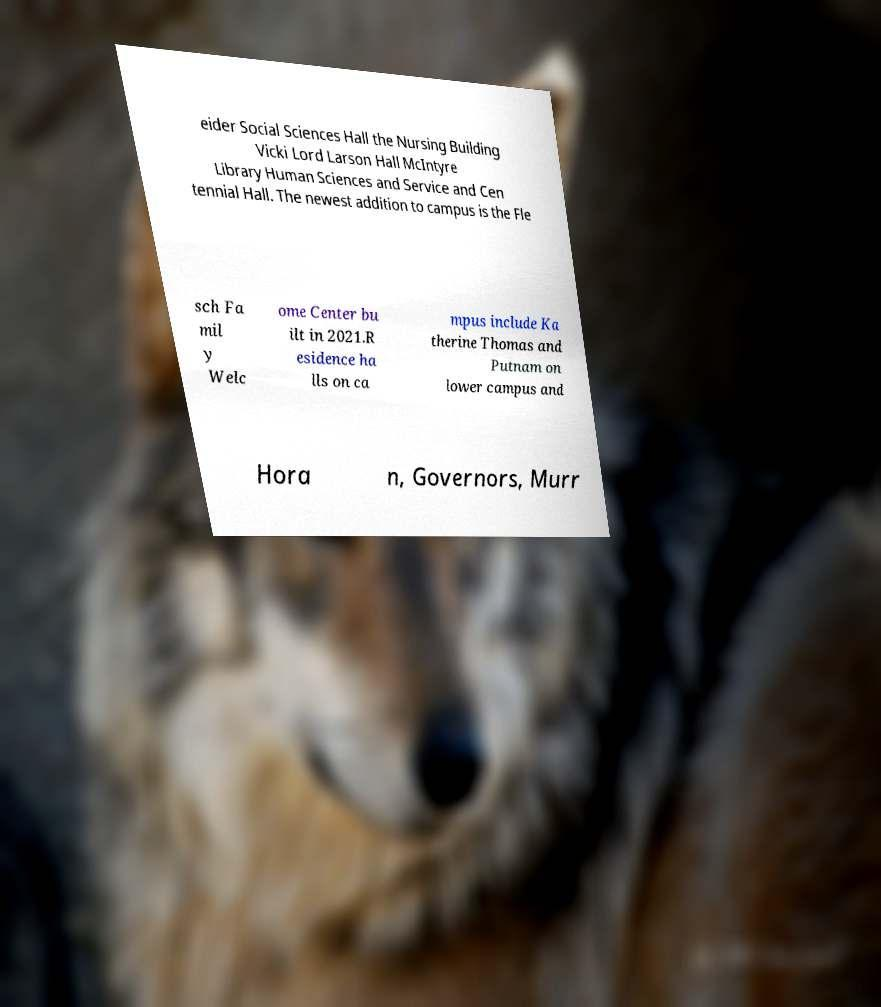For documentation purposes, I need the text within this image transcribed. Could you provide that? eider Social Sciences Hall the Nursing Building Vicki Lord Larson Hall McIntyre Library Human Sciences and Service and Cen tennial Hall. The newest addition to campus is the Fle sch Fa mil y Welc ome Center bu ilt in 2021.R esidence ha lls on ca mpus include Ka therine Thomas and Putnam on lower campus and Hora n, Governors, Murr 